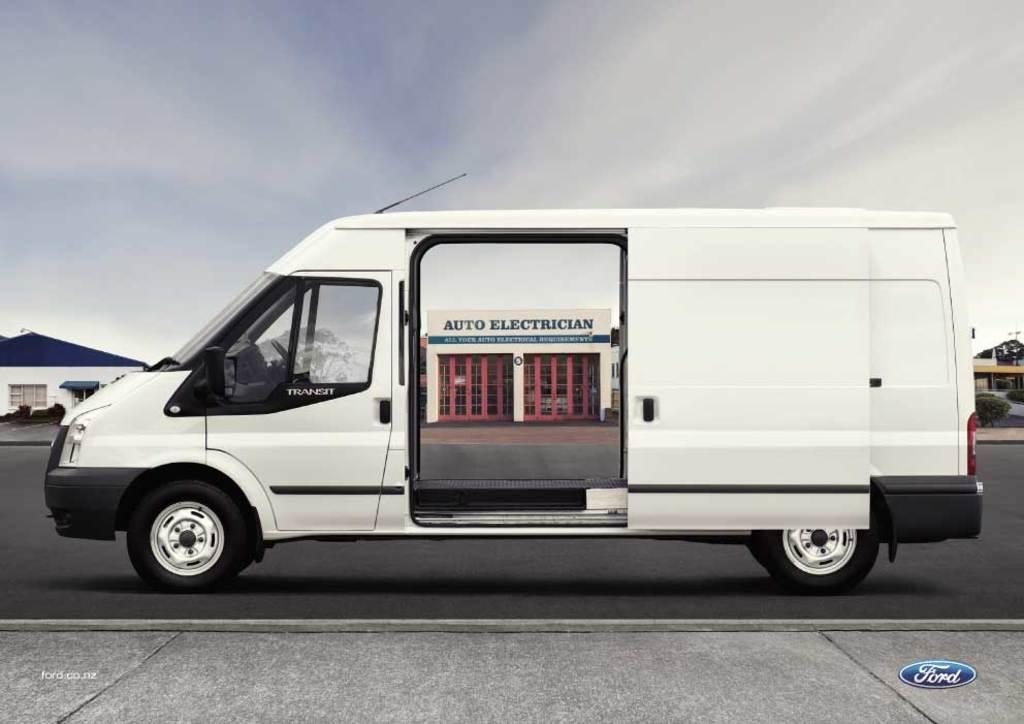Provide a one-sentence caption for the provided image. An auto electrician van with the store front on the outside of the van. 